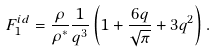<formula> <loc_0><loc_0><loc_500><loc_500>F _ { 1 } ^ { i d } = \frac { \rho } { \rho ^ { * } } \frac { 1 } { q ^ { 3 } } \left ( 1 + \frac { 6 q } { \sqrt { \pi } } + 3 q ^ { 2 } \right ) .</formula> 